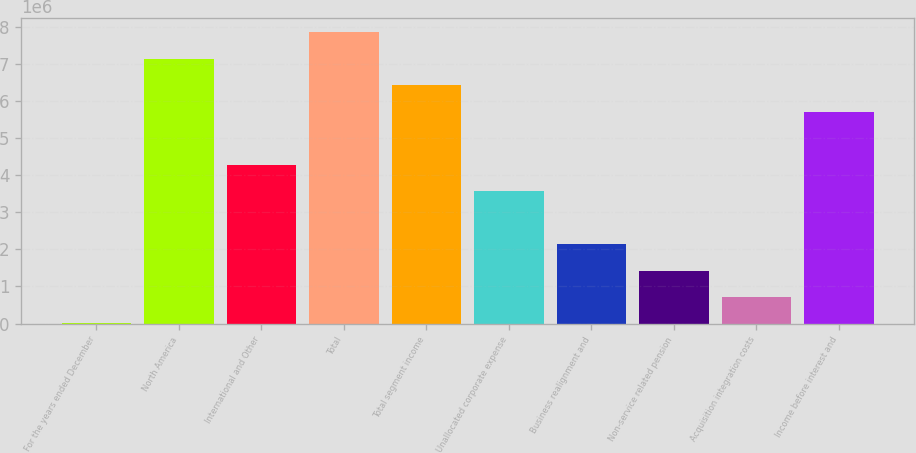Convert chart. <chart><loc_0><loc_0><loc_500><loc_500><bar_chart><fcel>For the years ended December<fcel>North America<fcel>International and Other<fcel>Total<fcel>Total segment income<fcel>Unallocated corporate expense<fcel>Business realignment and<fcel>Non-service related pension<fcel>Acquisition integration costs<fcel>Income before interest and<nl><fcel>2013<fcel>7.14608e+06<fcel>4.28845e+06<fcel>7.86049e+06<fcel>6.43167e+06<fcel>3.57405e+06<fcel>2.14523e+06<fcel>1.43083e+06<fcel>716420<fcel>5.71727e+06<nl></chart> 